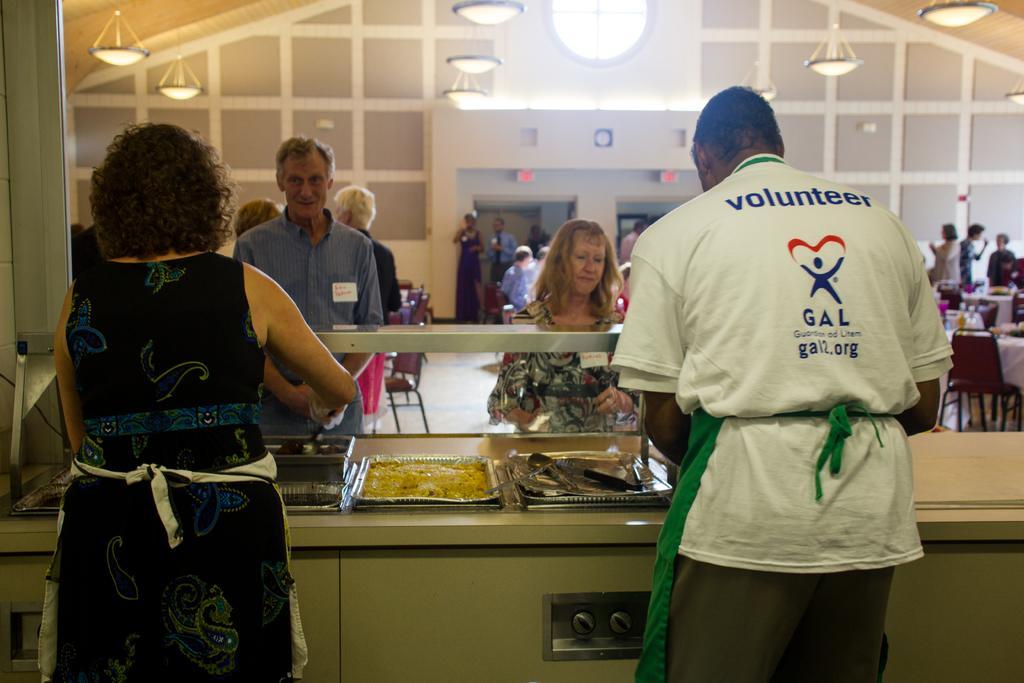Could you give a brief overview of what you see in this image? In this image we can see people, tables, bowls with food, chairs, floor, and lights. In the background we can see wall and boards. 